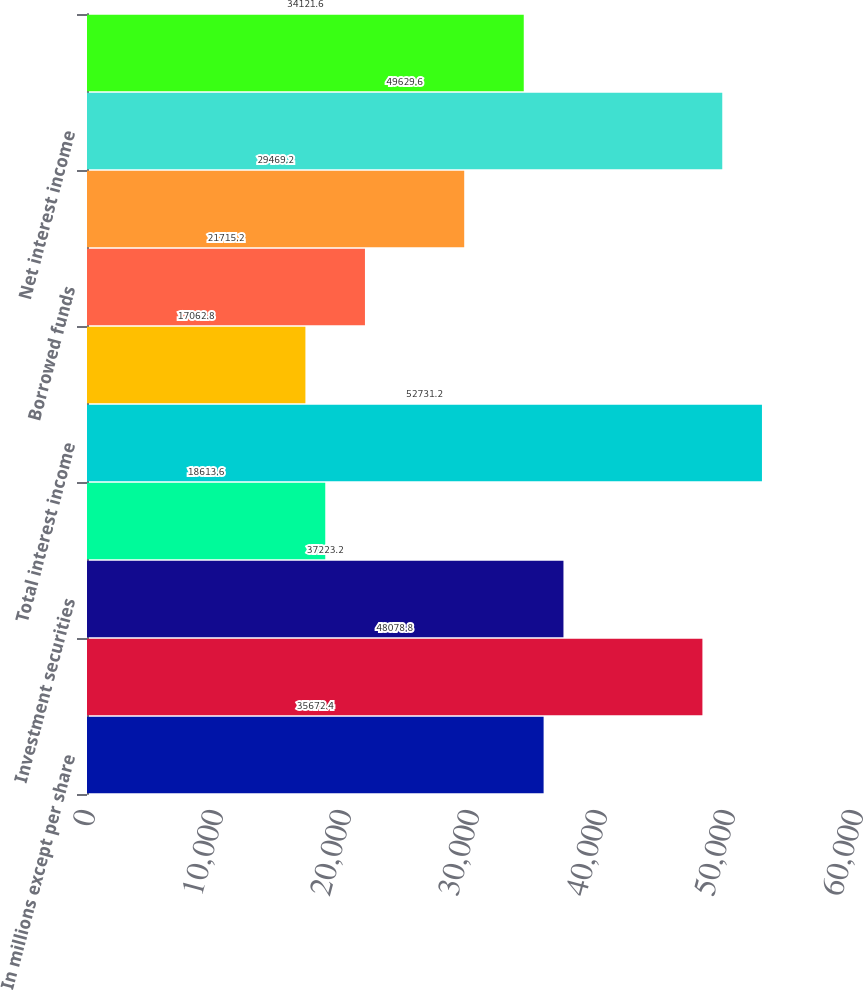Convert chart. <chart><loc_0><loc_0><loc_500><loc_500><bar_chart><fcel>In millions except per share<fcel>Loans<fcel>Investment securities<fcel>Other<fcel>Total interest income<fcel>Deposits<fcel>Borrowed funds<fcel>Total interest expense<fcel>Net interest income<fcel>Asset management<nl><fcel>35672.4<fcel>48078.8<fcel>37223.2<fcel>18613.6<fcel>52731.2<fcel>17062.8<fcel>21715.2<fcel>29469.2<fcel>49629.6<fcel>34121.6<nl></chart> 